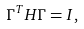<formula> <loc_0><loc_0><loc_500><loc_500>{ \Gamma } ^ { T } H { \Gamma } = I ,</formula> 